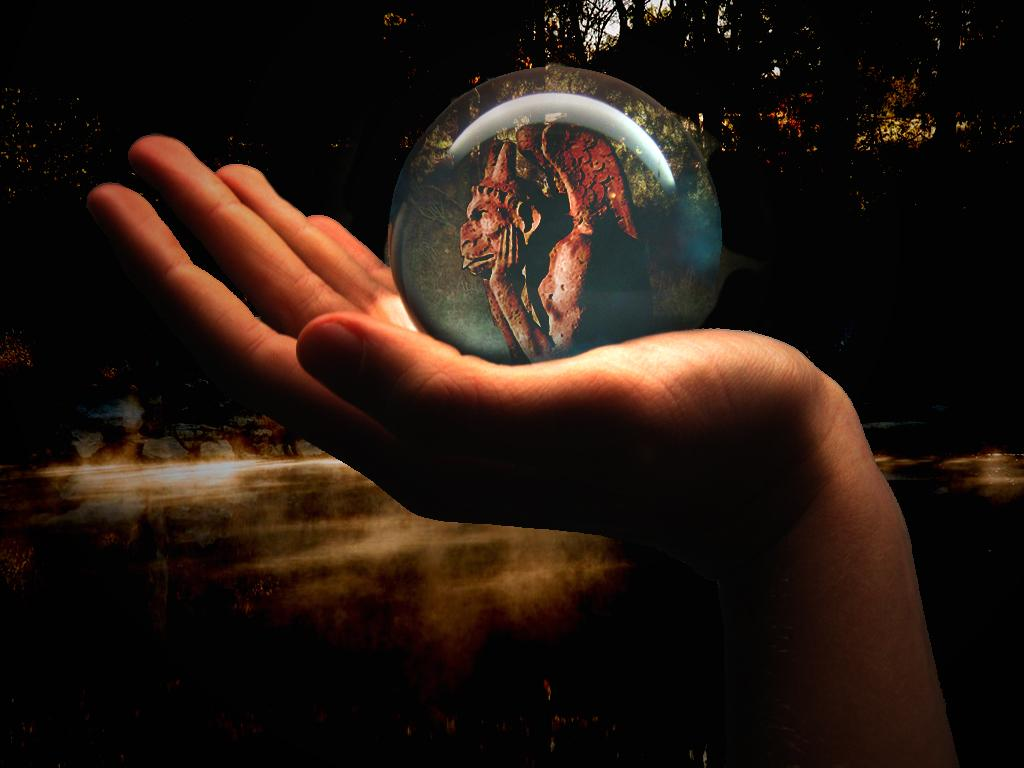What can be seen in the image related to a person's body part? There is a person's hand in the image. What is the hand holding? The hand is holding a round object. What can be seen in the background of the image? There are trees in the background of the image. What is inside the round object that the hand is holding? There is something visible inside the round object. How many units of ants can be seen crawling on the ground in the image? There are no ants or ground visible in the image. 